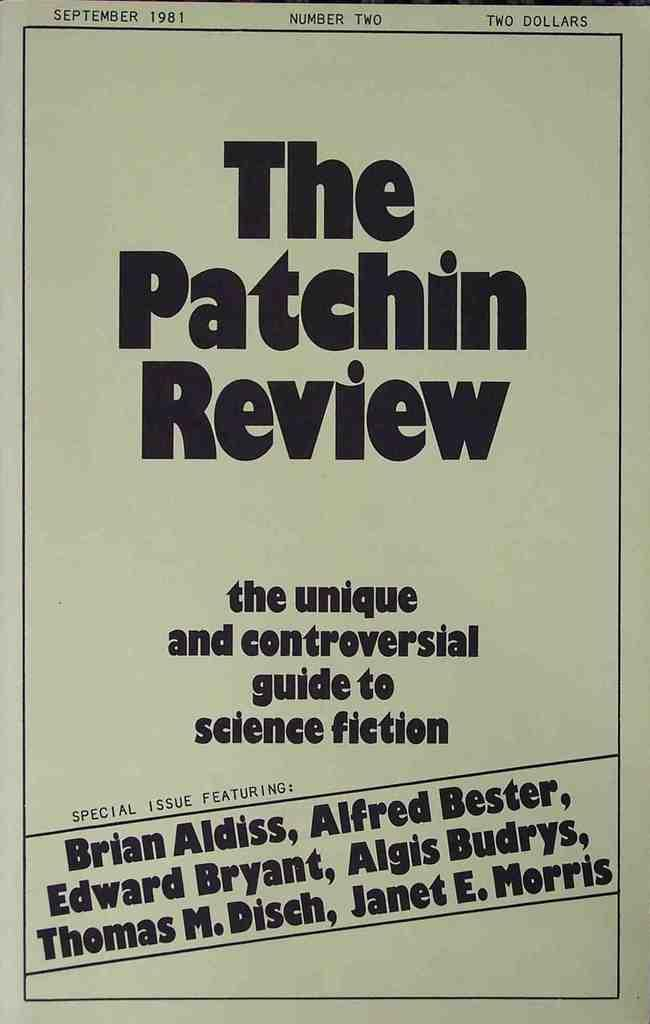<image>
Present a compact description of the photo's key features. A poster advertising a 'unique and controversial guide to science fiction.' 